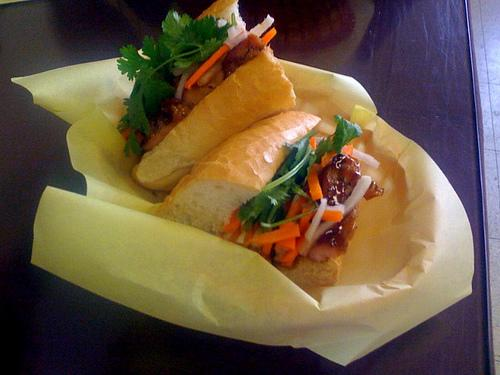How many individual sandwich pieces are in the image? Please explain your reasoning. two. The sandwich is very colorful. 